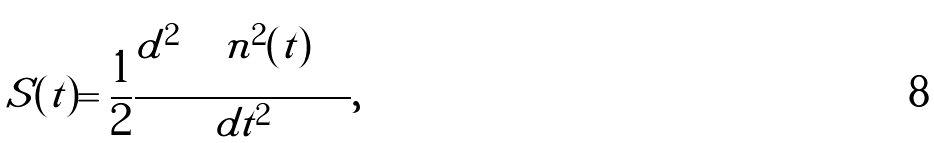Convert formula to latex. <formula><loc_0><loc_0><loc_500><loc_500>S ( t ) = \frac { 1 } { 2 } \frac { d ^ { 2 } \left \langle \left \langle n ^ { 2 } ( t ) \right \rangle \right \rangle } { d t ^ { 2 } } ,</formula> 